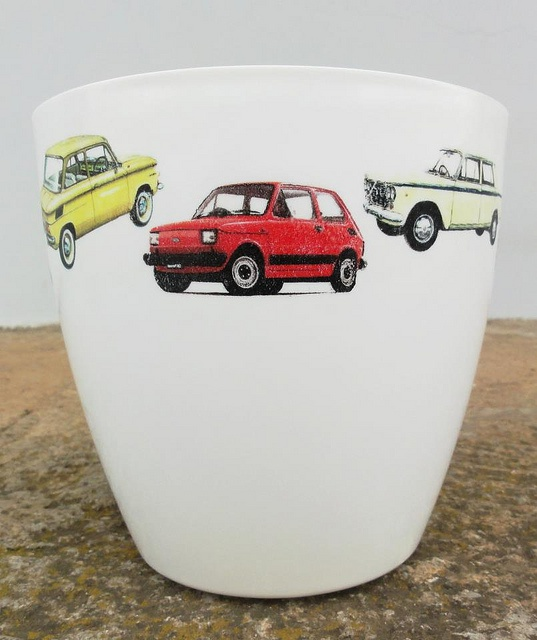Describe the objects in this image and their specific colors. I can see cup in lightgray, black, and darkgray tones, car in lightgray, black, and brown tones, car in lightgray, khaki, and gray tones, and car in lightgray, black, darkgray, and gray tones in this image. 